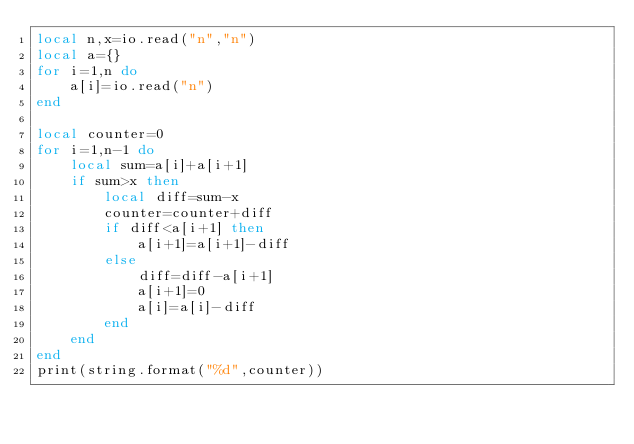<code> <loc_0><loc_0><loc_500><loc_500><_Lua_>local n,x=io.read("n","n")
local a={}
for i=1,n do
    a[i]=io.read("n")
end

local counter=0
for i=1,n-1 do
    local sum=a[i]+a[i+1]
    if sum>x then
        local diff=sum-x
        counter=counter+diff
        if diff<a[i+1] then
            a[i+1]=a[i+1]-diff
        else
            diff=diff-a[i+1]
            a[i+1]=0
            a[i]=a[i]-diff
        end
    end
end
print(string.format("%d",counter))</code> 